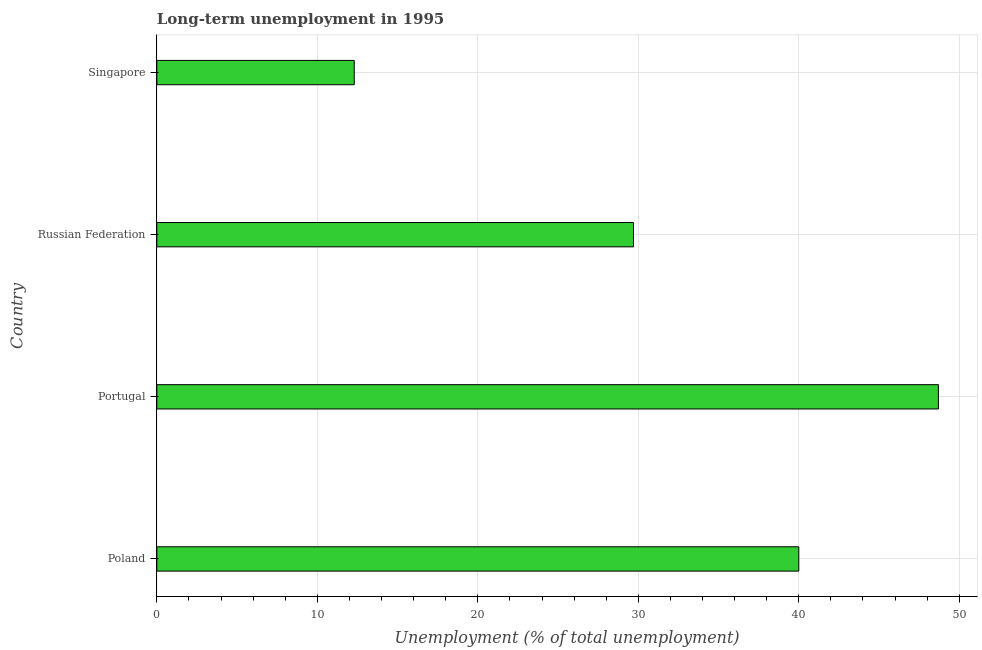What is the title of the graph?
Offer a terse response. Long-term unemployment in 1995. What is the label or title of the X-axis?
Keep it short and to the point. Unemployment (% of total unemployment). What is the long-term unemployment in Singapore?
Your answer should be very brief. 12.3. Across all countries, what is the maximum long-term unemployment?
Offer a terse response. 48.7. Across all countries, what is the minimum long-term unemployment?
Offer a terse response. 12.3. In which country was the long-term unemployment maximum?
Ensure brevity in your answer.  Portugal. In which country was the long-term unemployment minimum?
Make the answer very short. Singapore. What is the sum of the long-term unemployment?
Your answer should be very brief. 130.7. What is the difference between the long-term unemployment in Poland and Portugal?
Your answer should be compact. -8.7. What is the average long-term unemployment per country?
Your answer should be very brief. 32.67. What is the median long-term unemployment?
Ensure brevity in your answer.  34.85. What is the ratio of the long-term unemployment in Poland to that in Singapore?
Ensure brevity in your answer.  3.25. Is the difference between the long-term unemployment in Poland and Russian Federation greater than the difference between any two countries?
Ensure brevity in your answer.  No. Is the sum of the long-term unemployment in Portugal and Singapore greater than the maximum long-term unemployment across all countries?
Keep it short and to the point. Yes. What is the difference between the highest and the lowest long-term unemployment?
Your response must be concise. 36.4. Are all the bars in the graph horizontal?
Make the answer very short. Yes. What is the difference between two consecutive major ticks on the X-axis?
Provide a short and direct response. 10. Are the values on the major ticks of X-axis written in scientific E-notation?
Your response must be concise. No. What is the Unemployment (% of total unemployment) in Portugal?
Ensure brevity in your answer.  48.7. What is the Unemployment (% of total unemployment) of Russian Federation?
Offer a very short reply. 29.7. What is the Unemployment (% of total unemployment) in Singapore?
Ensure brevity in your answer.  12.3. What is the difference between the Unemployment (% of total unemployment) in Poland and Portugal?
Ensure brevity in your answer.  -8.7. What is the difference between the Unemployment (% of total unemployment) in Poland and Russian Federation?
Ensure brevity in your answer.  10.3. What is the difference between the Unemployment (% of total unemployment) in Poland and Singapore?
Provide a succinct answer. 27.7. What is the difference between the Unemployment (% of total unemployment) in Portugal and Russian Federation?
Provide a short and direct response. 19. What is the difference between the Unemployment (% of total unemployment) in Portugal and Singapore?
Provide a succinct answer. 36.4. What is the ratio of the Unemployment (% of total unemployment) in Poland to that in Portugal?
Your response must be concise. 0.82. What is the ratio of the Unemployment (% of total unemployment) in Poland to that in Russian Federation?
Make the answer very short. 1.35. What is the ratio of the Unemployment (% of total unemployment) in Poland to that in Singapore?
Make the answer very short. 3.25. What is the ratio of the Unemployment (% of total unemployment) in Portugal to that in Russian Federation?
Provide a succinct answer. 1.64. What is the ratio of the Unemployment (% of total unemployment) in Portugal to that in Singapore?
Your answer should be very brief. 3.96. What is the ratio of the Unemployment (% of total unemployment) in Russian Federation to that in Singapore?
Your response must be concise. 2.42. 